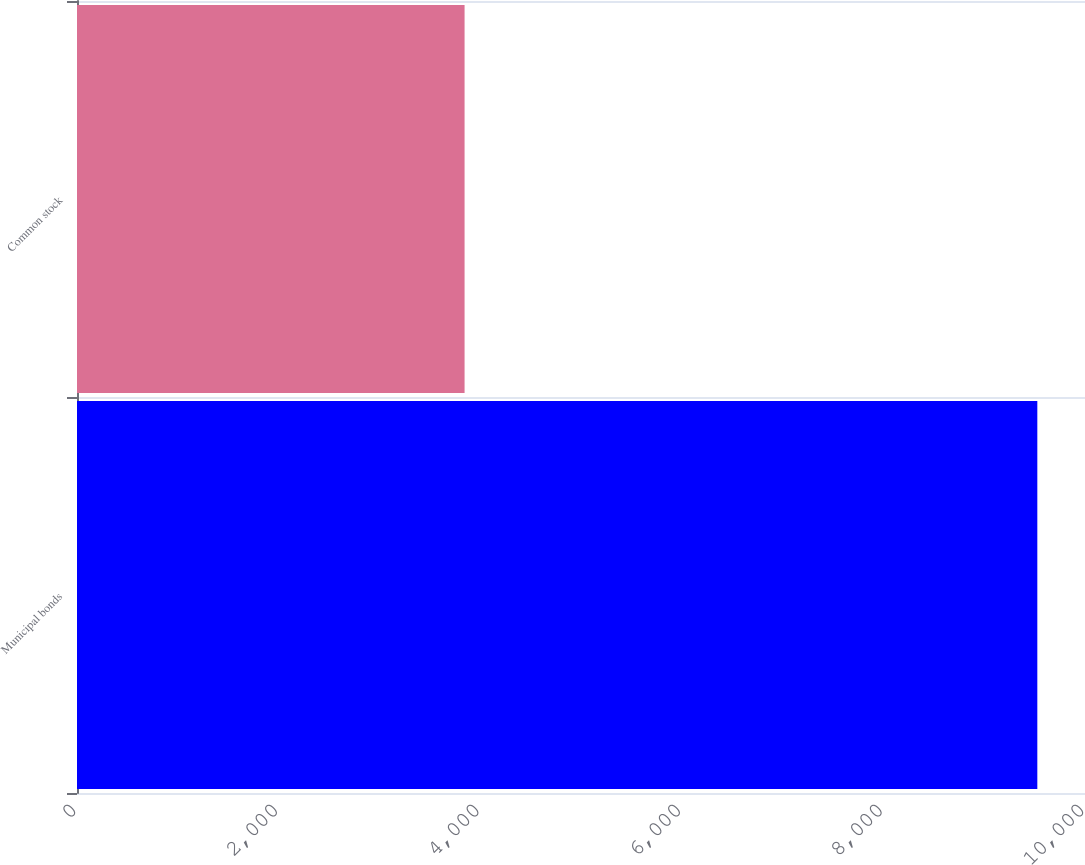Convert chart to OTSL. <chart><loc_0><loc_0><loc_500><loc_500><bar_chart><fcel>Municipal bonds<fcel>Common stock<nl><fcel>9527<fcel>3845<nl></chart> 